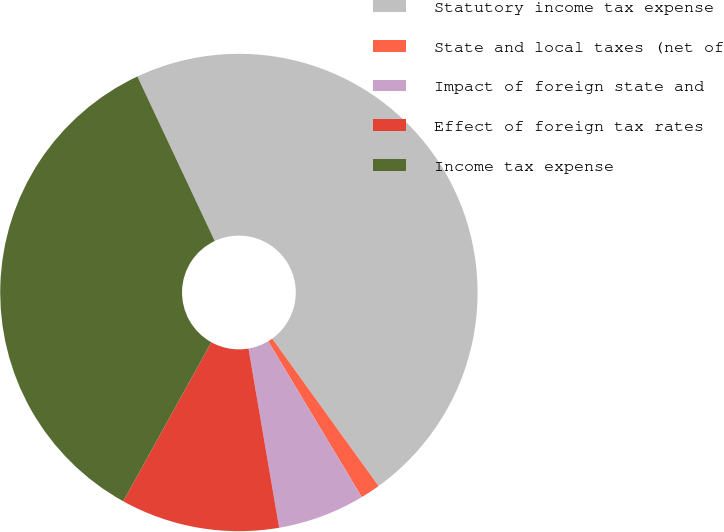Convert chart. <chart><loc_0><loc_0><loc_500><loc_500><pie_chart><fcel>Statutory income tax expense<fcel>State and local taxes (net of<fcel>Impact of foreign state and<fcel>Effect of foreign tax rates<fcel>Income tax expense<nl><fcel>47.04%<fcel>1.34%<fcel>5.91%<fcel>10.75%<fcel>34.95%<nl></chart> 